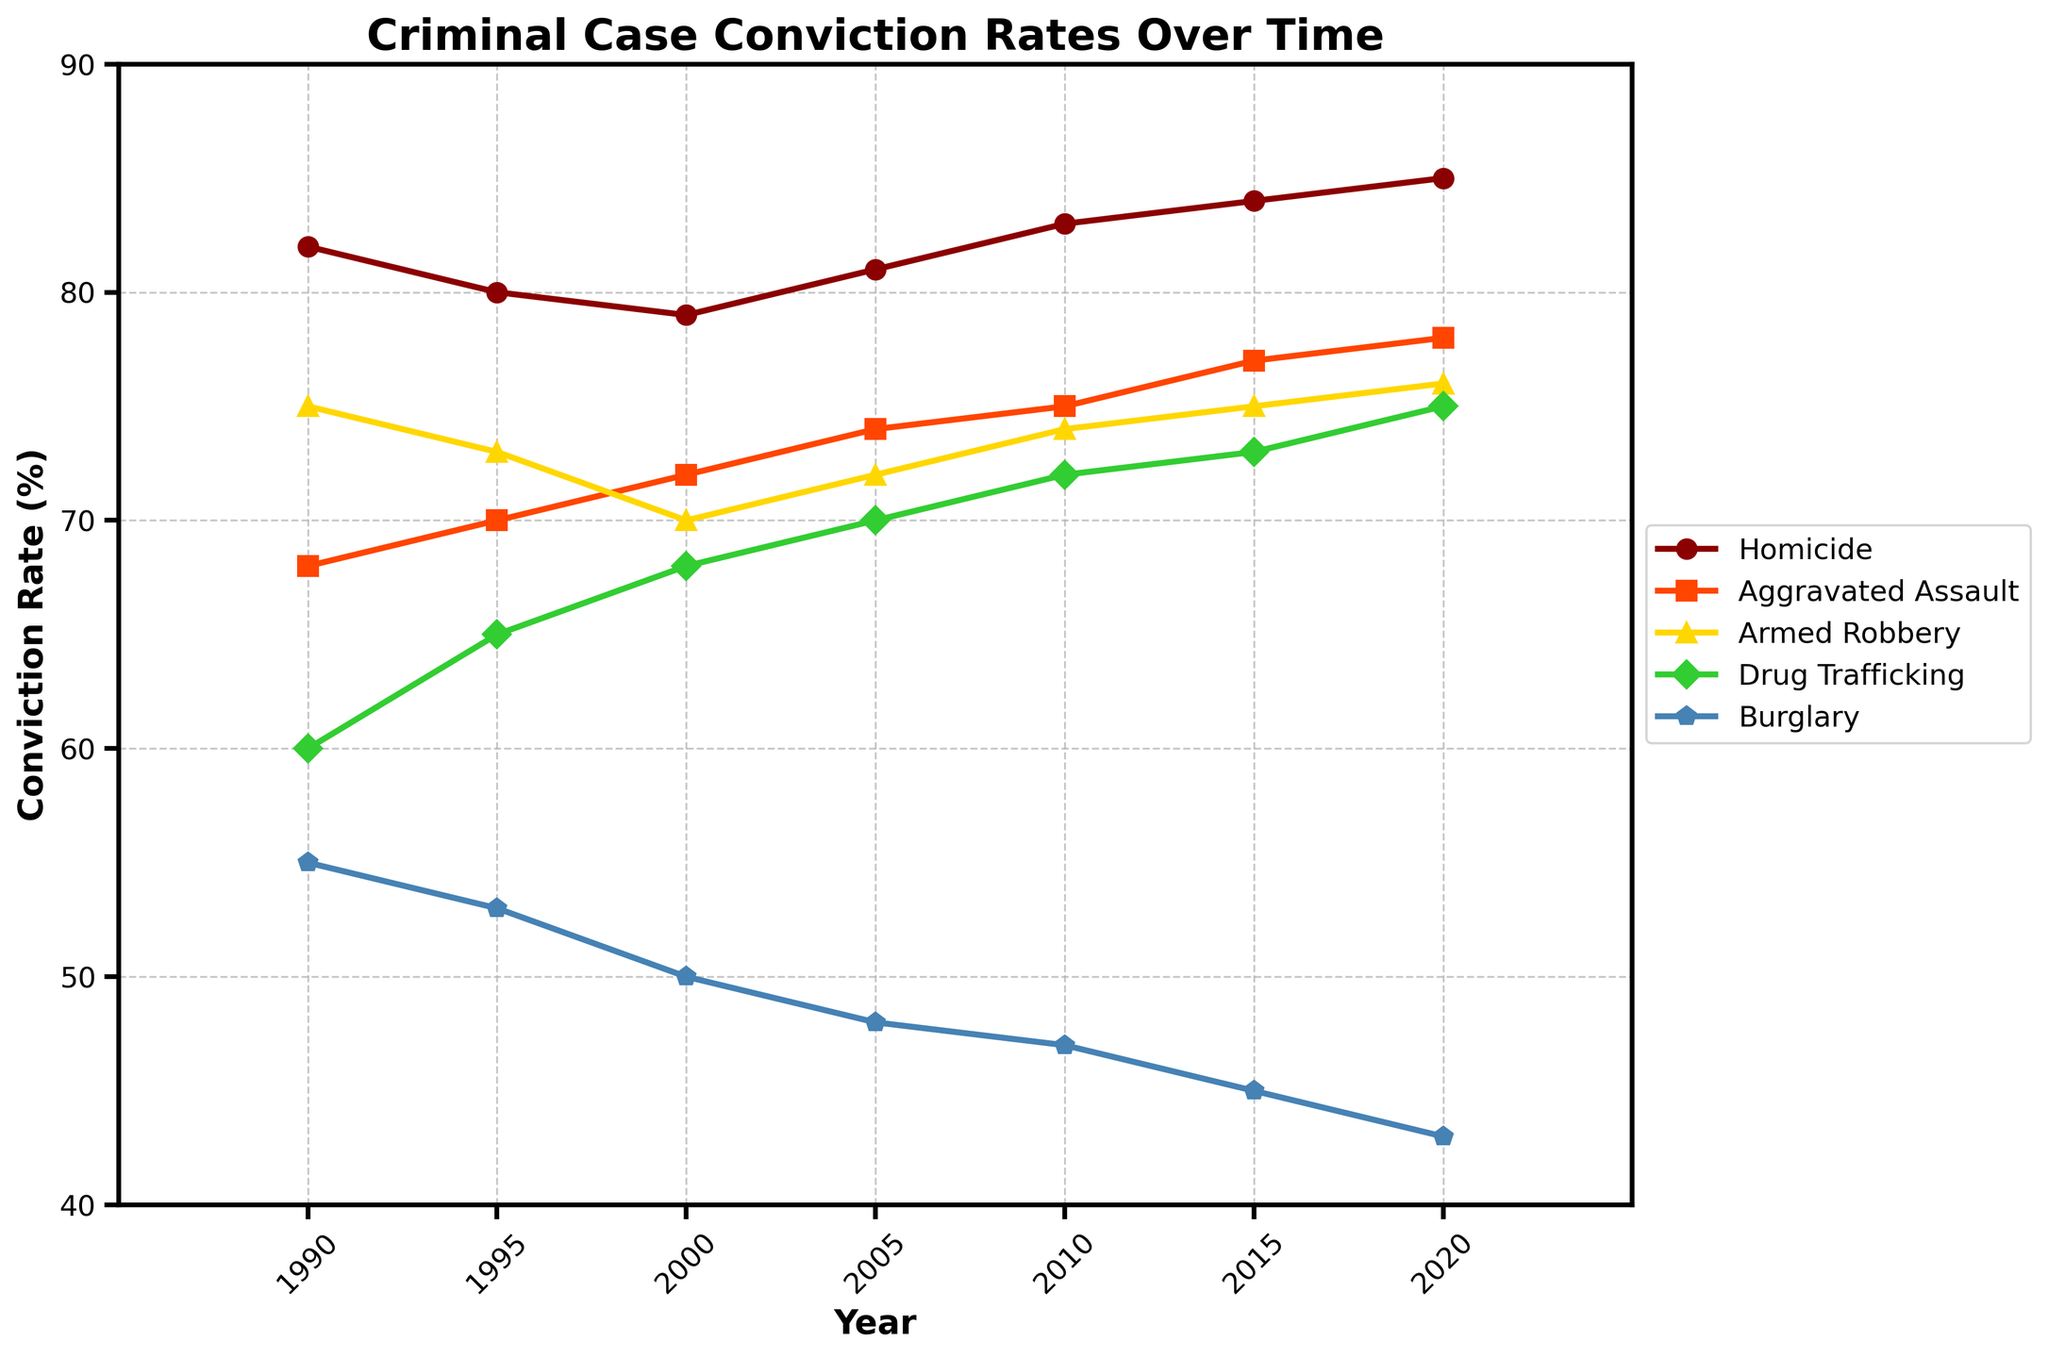What's the conviction rate for Homicide in 2005? Locate the year 2005 on the x-axis, then follow the line corresponding to Homicide to see its value.
Answer: 81% Which crime type had the lowest conviction rate in 2020? Locate the year 2020 on the x-axis and compare the end points of all lines to find the lowest one.
Answer: Burglary How has the conviction rate for Drug Trafficking changed from 1990 to 2020? Check the values for Drug Trafficking in 1990 and 2020, and calculate the difference. 60% in 1990 and 75% in 2020. The change is 75% - 60% = 15%.
Answer: Increased by 15% Which crime had the highest increase in conviction rates from 1990 to 2020? Calculate the difference in rates for each crime from 1990 to 2020, and compare to find the highest increase. Homicide: 85-82 = 3%, Aggravated Assault: 78-68 = 10%, Armed Robbery: 76-75 = 1%, Drug Trafficking: 75-60 = 15%, Burglary: 43-55 = -12%.
Answer: Drug Trafficking What’s the average conviction rate for Aggravated Assault over the years provided? Sum the values for Aggravated Assault (68 + 70 + 72 + 74 + 75 + 77 + 78), then divide by the number of years (7). Average = (68 + 70 + 72 + 74 + 75 + 77 + 78) / 7 ≈ 73.43
Answer: 73.43% How do the conviction rates for Homicide and Armed Robbery in 2010 compare? Find and compare the values for Homicide and Armed Robbery in the year 2010. Homicide is 83%, and Armed Robbery is 74%.
Answer: Homicide is higher Which crime type has the most consistent conviction rate trend over the years? Observe the lines for each crime type and determine which has the smoothest, least-variable trend. Homicide shows a steady trend.
Answer: Homicide During which year did Burglary conviction rates drop to below 50% for the first time? Locate the points on the Burglary line where the value first drops below 50%. In 2000 the rate is above 50%, but in 2005 it drops to 48%.
Answer: 2005 